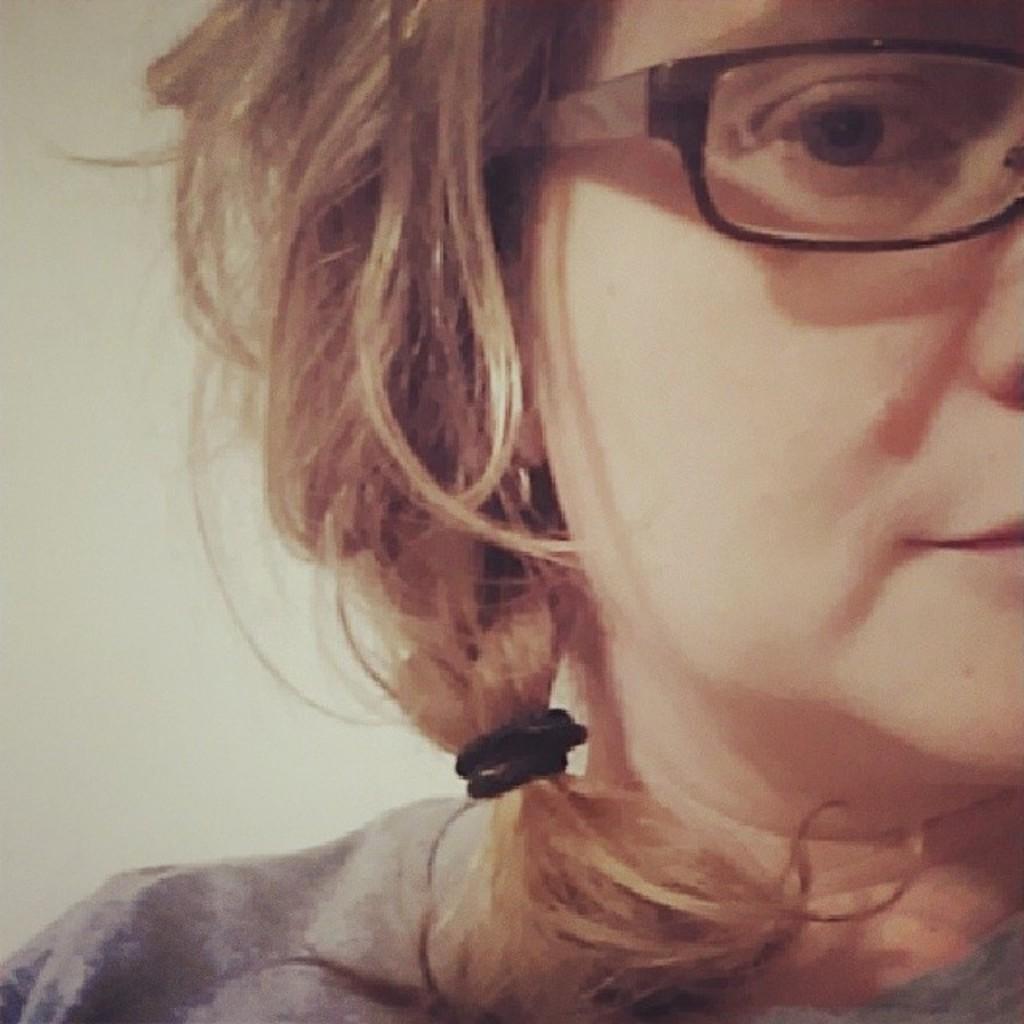Can you describe this image briefly? This image is taken indoors. In the background there is a wall. On the right side of the image there is a girl. She has worn a T-shirt and spectacle. 